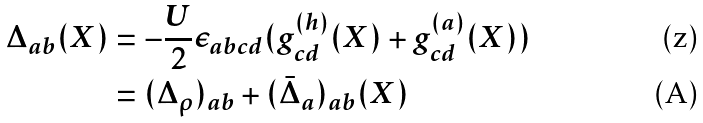Convert formula to latex. <formula><loc_0><loc_0><loc_500><loc_500>\Delta _ { a b } ( X ) & = - \frac { U } { 2 } \epsilon _ { a b c d } ( g ^ { ( h ) } _ { c d } ( X ) + g ^ { ( a ) } _ { c d } ( X ) ) \\ & = ( \Delta _ { \rho } ) _ { a b } + ( \bar { \Delta } _ { a } ) _ { a b } ( X )</formula> 